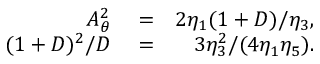<formula> <loc_0><loc_0><loc_500><loc_500>\begin{array} { r l r } { A _ { \theta } ^ { 2 } } & = } & { 2 \eta _ { 1 } ( 1 + D ) / \eta _ { 3 } , } \\ { ( 1 + D ) ^ { 2 } / D } & = } & { 3 \eta _ { 3 } ^ { 2 } / ( 4 \eta _ { 1 } \eta _ { 5 } ) . } \end{array}</formula> 